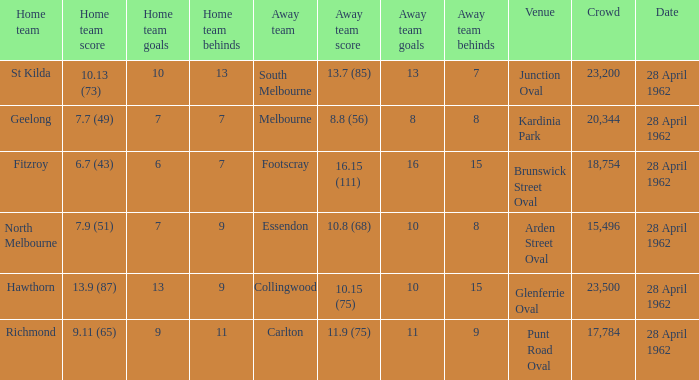At what venue did an away team score 10.15 (75)? Glenferrie Oval. 